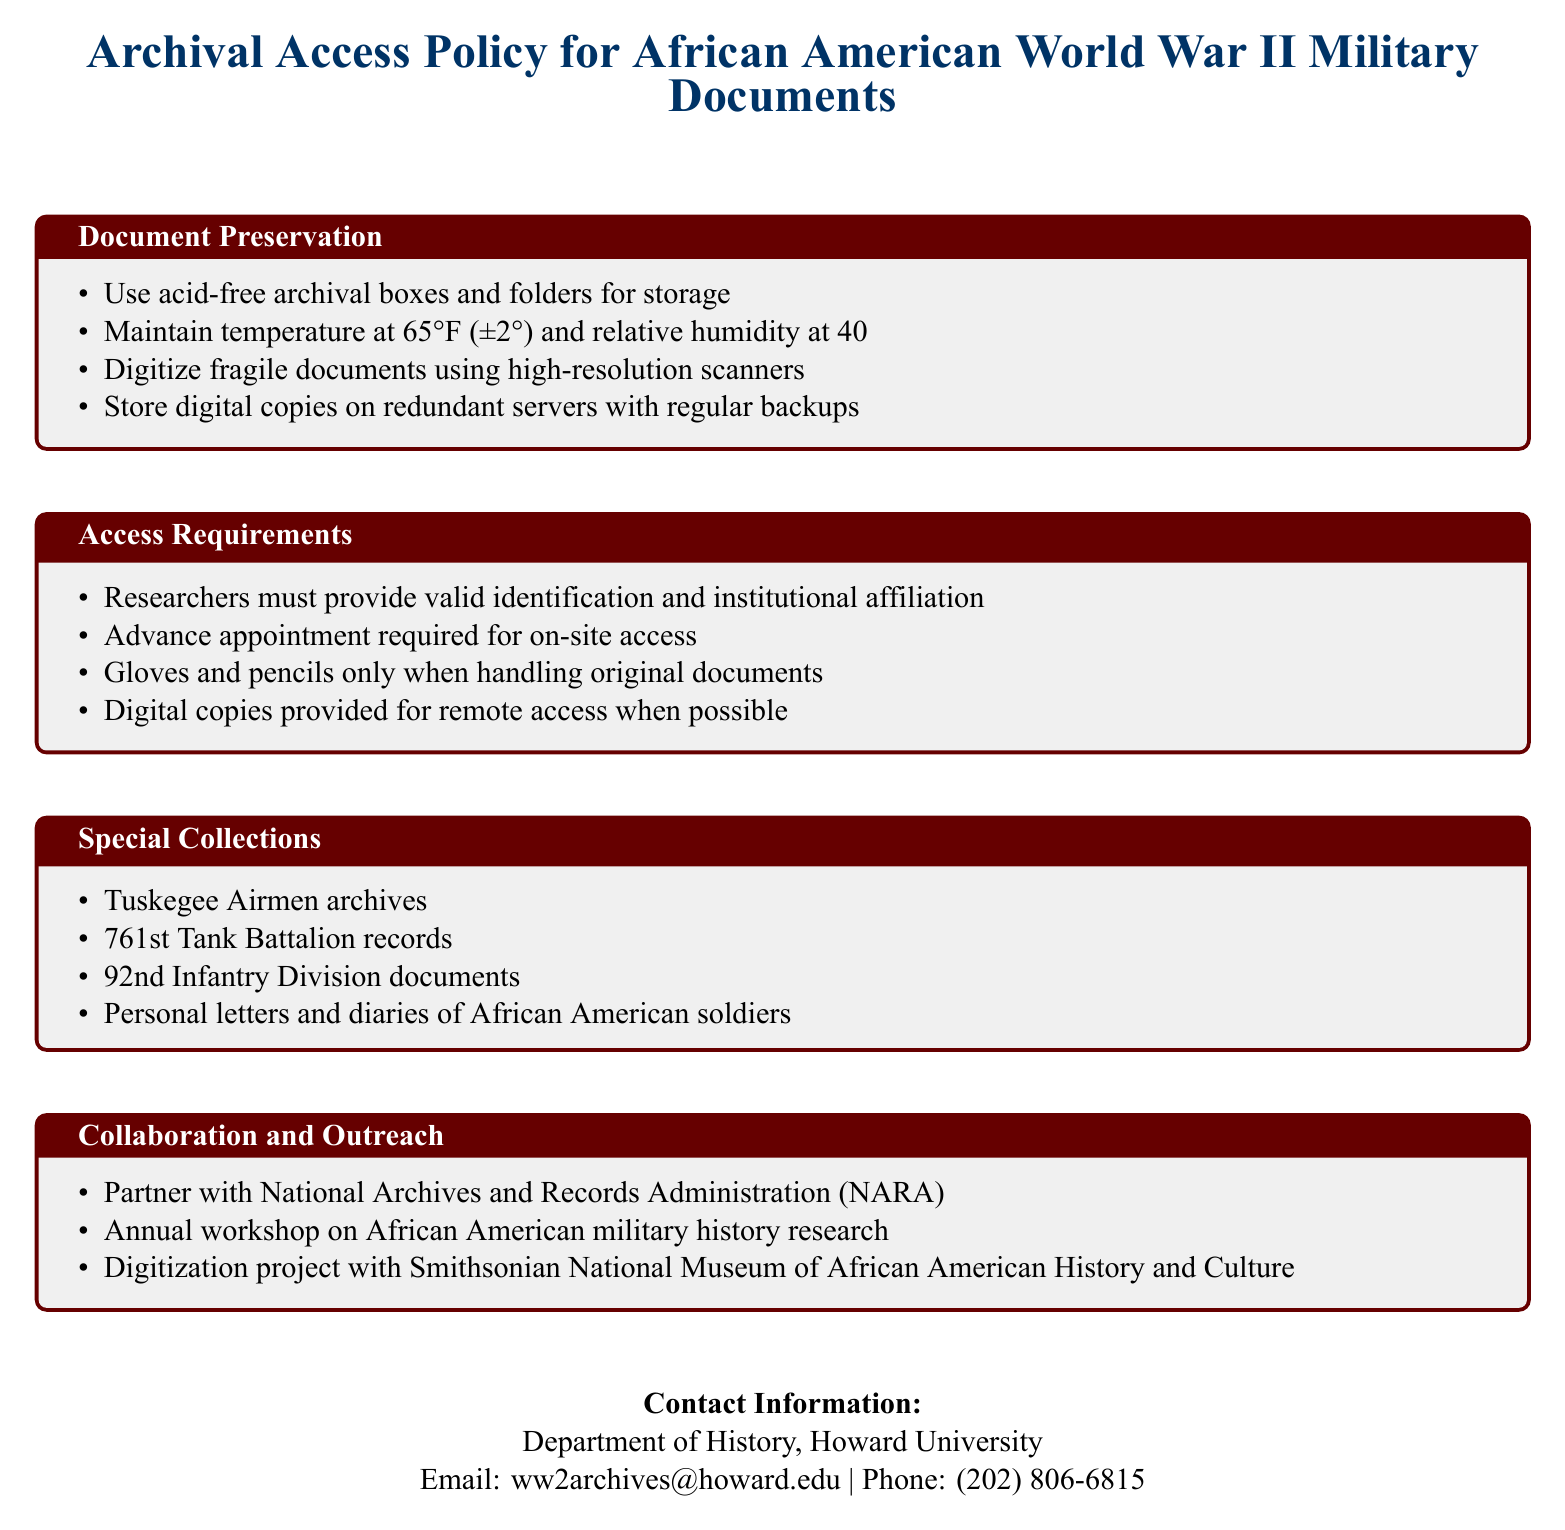What is the required temperature for document storage? The document specifies that the temperature should be maintained at 65°F (±2°).
Answer: 65°F (±2°) What type of boxes should be used for document preservation? The policy states that acid-free archival boxes and folders should be used for storage.
Answer: Acid-free archival boxes and folders What is the relative humidity requirement? The document indicates that relative humidity should be maintained at 40% (±5%).
Answer: 40% (±5%) Who must provide valid identification? The access requirements state that researchers must provide valid identification and institutional affiliation.
Answer: Researchers What archives are included in special collections? The document mentions several archives, including the Tuskegee Airmen archives.
Answer: Tuskegee Airmen archives What type of project is mentioned in collaboration and outreach? The document refers to a digitization project with the Smithsonian National Museum of African American History and Culture.
Answer: Digitization project How many access requirements are listed? There are four specific access requirements outlined in the document.
Answer: Four What item is prohibited during handling of original documents? The access requirements stipulate that only gloves and pencils are allowed when handling original documents.
Answer: Pens What is the primary purpose of the policy document? The document's purpose is to outline the archival access policy for historical documents related to African American military units in World War II.
Answer: Archival access policy 